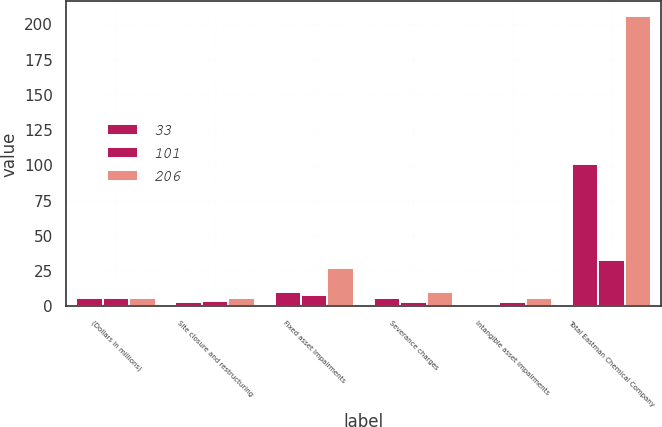Convert chart to OTSL. <chart><loc_0><loc_0><loc_500><loc_500><stacked_bar_chart><ecel><fcel>(Dollars in millions)<fcel>Site closure and restructuring<fcel>Fixed asset impairments<fcel>Severance charges<fcel>Intangible asset impairments<fcel>Total Eastman Chemical Company<nl><fcel>33<fcel>6<fcel>3<fcel>10<fcel>6<fcel>1<fcel>101<nl><fcel>101<fcel>6<fcel>4<fcel>8<fcel>3<fcel>3<fcel>33<nl><fcel>206<fcel>6<fcel>6<fcel>27<fcel>10<fcel>6<fcel>206<nl></chart> 